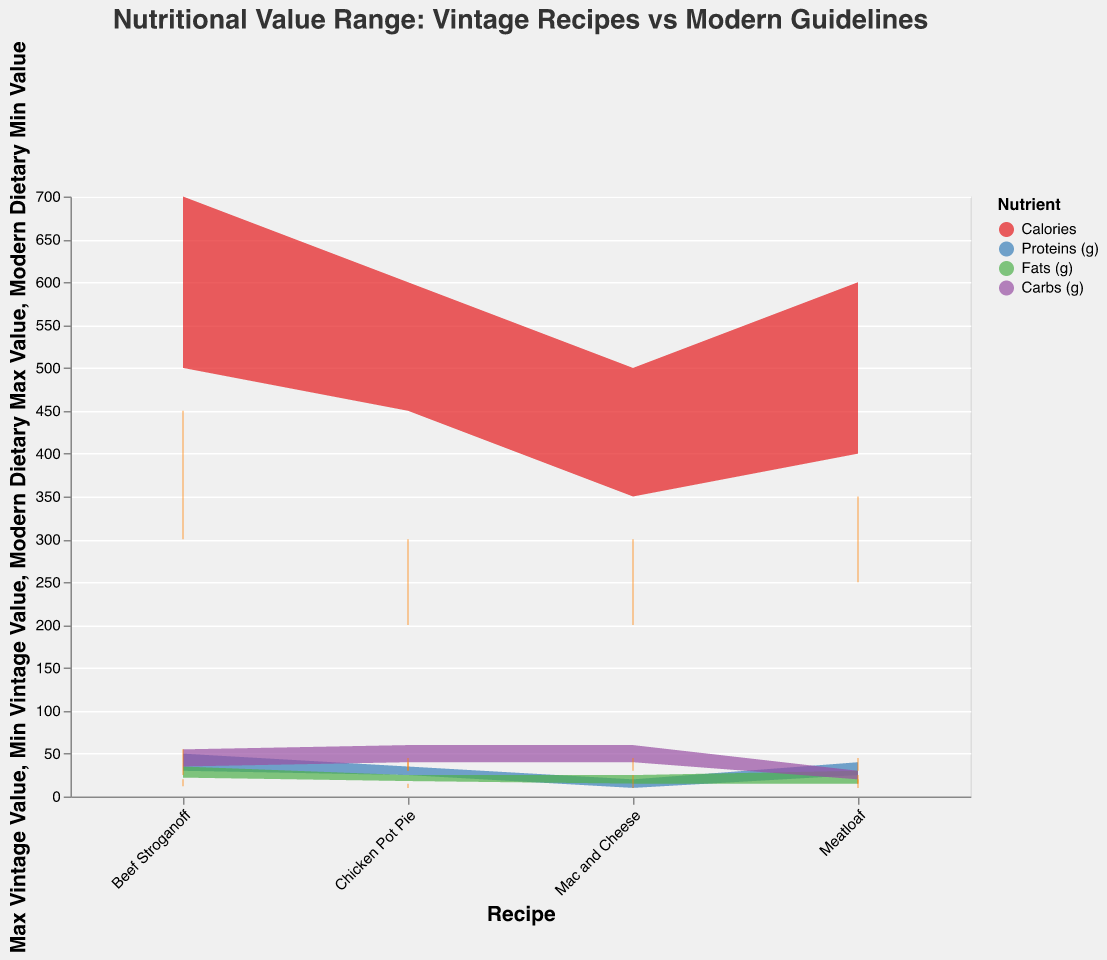How many different nutrients are analyzed in the figure? There are four nutrients analyzed: Calories, Proteins (g), Fats (g), and Carbs (g). These nutrients are represented by different colors in the legend.
Answer: Four What recipe shows the highest range of calories in vintage recipes? By looking at the range of calories, Beef Stroganoff shows the range from 500 to 700, which is the highest among all recipes.
Answer: Beef Stroganoff Which nutrient has the closest match between vintage and modern dietary fat values for Chicken Pot Pie? For Chicken Pot Pie, the fats in vintage recipes range from 18 to 25, while modern dietary values range from 10 to 15. Compared to other nutrients like calories, proteins, and carbs, fats have more overlap in values.
Answer: Fats What is the average minimum vintage value of calories for all recipes? The minimum vintage values for calories in each recipe are 450, 500, 350, and 400. Summing these gives 1700. Dividing by 4 recipes, the average is 425.
Answer: 425 For which recipe do the vintage protein values fall outside the modern dietary range for proteins? The vintage values for proteins in Mac and Cheese range from 10 to 20, while the modern dietary values range from 15 to 25. So, Mac and Cheese falls outside the modern dietary range.
Answer: Mac and Cheese Which nutrient's modern dietary values are always within the vintage range for all recipes? Comparing all nutrients for the overlap between vintage and modern dietary values across all recipes, Proteins (g) always fall within the vintage ranges.
Answer: Proteins (g) How do the fat values compare between modern and vintage recipes for Beef Stroganoff? The vintage fat values for Beef Stroganoff range from 22 to 35, while modern dietary values range from 12 to 20. The vintage values are higher by comparison.
Answer: Vintage values are higher What is the range difference for carbs between vintage and modern dietary values for Mac and Cheese? The range for carbs in vintage recipes is from 40 to 60, while for modern dietary values it is from 30 to 45. The difference in the range length is (60-40) - (45-30) = 20 - 15 = 5.
Answer: 5 Which nutrient in Meatloaf meets modern dietary guidelines more closely based on the overlap of values? The proteins in vintage Meatloaf range from 25 to 40, and modern values range from 30 to 45. The overlap is from 30 to 40, suggesting proteins more closely align.
Answer: Proteins What is the maximum vintage value for carbs in Chicken Pot Pie, and how does it compare to the maximum modern dietary value? The maximum vintage value for carbs in Chicken Pot Pie is 60, while the maximum modern dietary value is 45, showing that the vintage value is higher.
Answer: 60, higher 